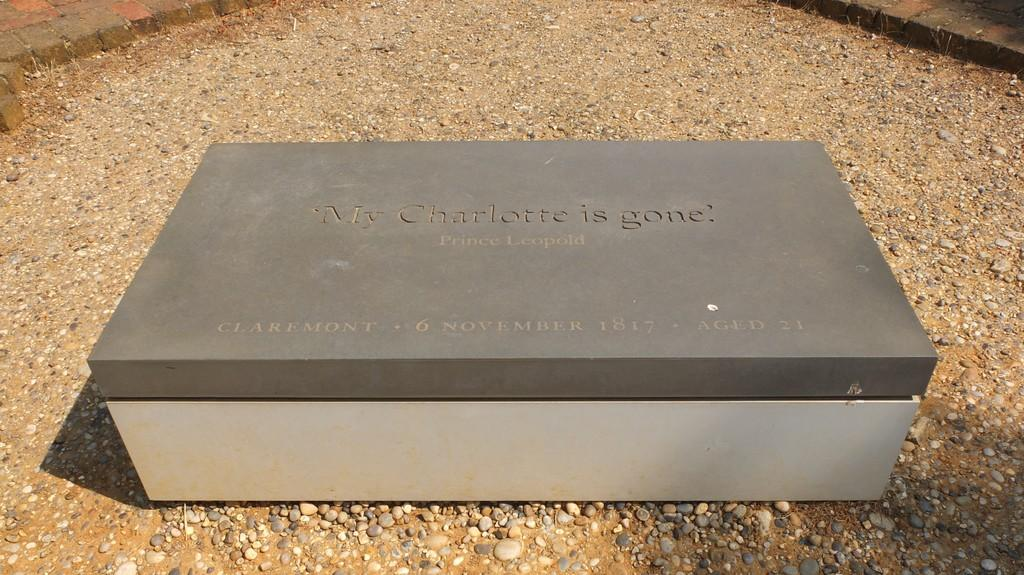<image>
Give a short and clear explanation of the subsequent image. A box has My Charlotte is gone? Written on the top. 